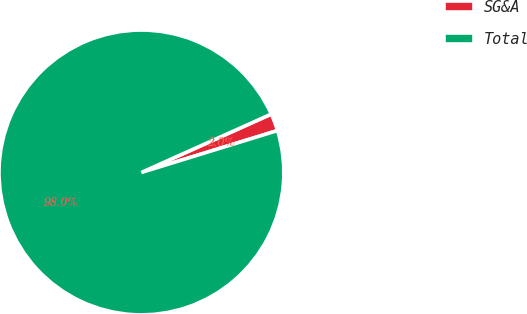Convert chart. <chart><loc_0><loc_0><loc_500><loc_500><pie_chart><fcel>SG&A<fcel>Total<nl><fcel>1.97%<fcel>98.03%<nl></chart> 